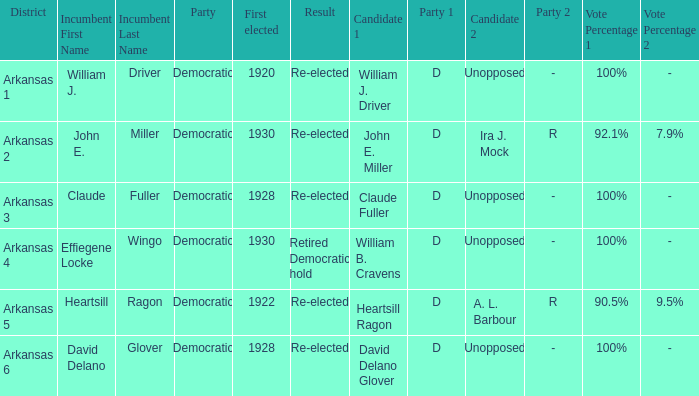What year was incumbent Claude Fuller first elected?  1928.0. 